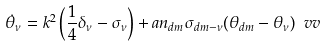Convert formula to latex. <formula><loc_0><loc_0><loc_500><loc_500>\dot { \theta } _ { \nu } = k ^ { 2 } \left ( \frac { 1 } { 4 } \delta _ { \nu } - \sigma _ { \nu } \right ) + a n _ { d m } \sigma _ { d m - \nu } ( \theta _ { d m } - \theta _ { \nu } ) \ v v</formula> 